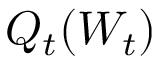<formula> <loc_0><loc_0><loc_500><loc_500>Q _ { t } ( W _ { t } )</formula> 